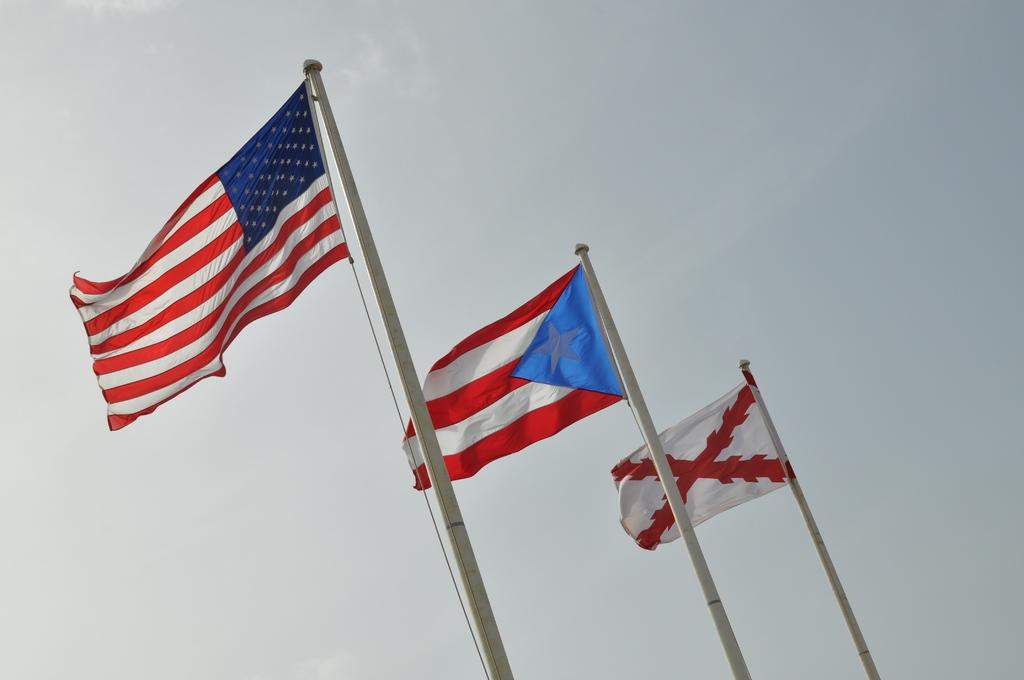How many flags are present in the image? There are three flags in the image. How are the flags supported in the image? The flags are attached to poles. What can be seen in the background of the image? The sky is visible in the background of the image. How many sheep are grazing near the flags in the image? There are no sheep present in the image; it only features flags attached to poles. 